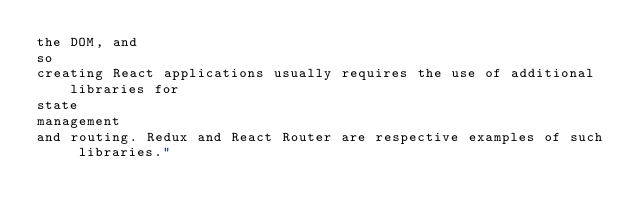<code> <loc_0><loc_0><loc_500><loc_500><_HTML_>the DOM, and
so
creating React applications usually requires the use of additional libraries for
state
management
and routing. Redux and React Router are respective examples of such libraries."</code> 